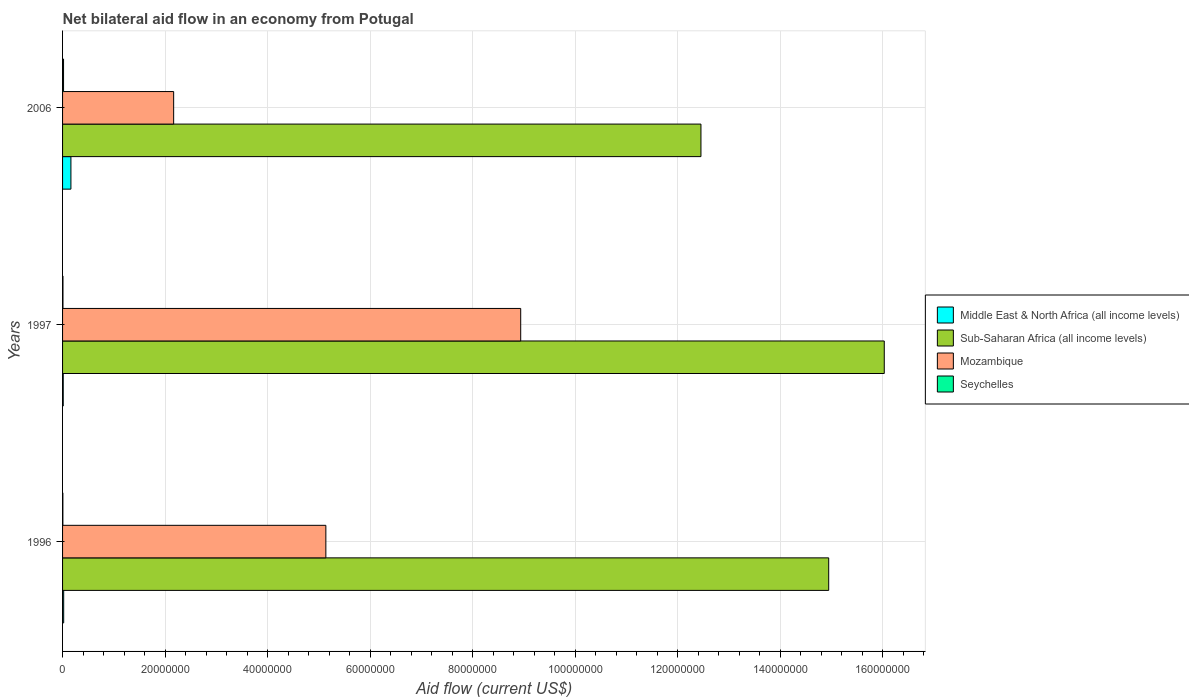How many different coloured bars are there?
Keep it short and to the point. 4. How many groups of bars are there?
Offer a very short reply. 3. Are the number of bars on each tick of the Y-axis equal?
Offer a very short reply. Yes. How many bars are there on the 2nd tick from the top?
Offer a terse response. 4. In how many cases, is the number of bars for a given year not equal to the number of legend labels?
Make the answer very short. 0. What is the net bilateral aid flow in Middle East & North Africa (all income levels) in 1997?
Make the answer very short. 1.30e+05. Across all years, what is the maximum net bilateral aid flow in Seychelles?
Offer a very short reply. 1.90e+05. Across all years, what is the minimum net bilateral aid flow in Sub-Saharan Africa (all income levels)?
Keep it short and to the point. 1.25e+08. In which year was the net bilateral aid flow in Mozambique minimum?
Offer a very short reply. 2006. What is the total net bilateral aid flow in Mozambique in the graph?
Offer a very short reply. 1.62e+08. What is the difference between the net bilateral aid flow in Sub-Saharan Africa (all income levels) in 1996 and that in 1997?
Offer a very short reply. -1.08e+07. What is the difference between the net bilateral aid flow in Middle East & North Africa (all income levels) in 2006 and the net bilateral aid flow in Sub-Saharan Africa (all income levels) in 1997?
Offer a very short reply. -1.59e+08. What is the average net bilateral aid flow in Middle East & North Africa (all income levels) per year?
Offer a terse response. 6.60e+05. In the year 1997, what is the difference between the net bilateral aid flow in Sub-Saharan Africa (all income levels) and net bilateral aid flow in Mozambique?
Give a very brief answer. 7.09e+07. What is the ratio of the net bilateral aid flow in Mozambique in 1996 to that in 2006?
Your answer should be compact. 2.37. What is the difference between the highest and the second highest net bilateral aid flow in Sub-Saharan Africa (all income levels)?
Make the answer very short. 1.08e+07. What is the difference between the highest and the lowest net bilateral aid flow in Mozambique?
Give a very brief answer. 6.77e+07. Is the sum of the net bilateral aid flow in Mozambique in 1996 and 1997 greater than the maximum net bilateral aid flow in Sub-Saharan Africa (all income levels) across all years?
Your answer should be compact. No. What does the 2nd bar from the top in 1996 represents?
Make the answer very short. Mozambique. What does the 1st bar from the bottom in 1997 represents?
Ensure brevity in your answer.  Middle East & North Africa (all income levels). How many bars are there?
Provide a succinct answer. 12. How many years are there in the graph?
Your answer should be very brief. 3. Does the graph contain any zero values?
Your response must be concise. No. How are the legend labels stacked?
Provide a succinct answer. Vertical. What is the title of the graph?
Your answer should be very brief. Net bilateral aid flow in an economy from Potugal. What is the Aid flow (current US$) of Middle East & North Africa (all income levels) in 1996?
Keep it short and to the point. 2.20e+05. What is the Aid flow (current US$) in Sub-Saharan Africa (all income levels) in 1996?
Ensure brevity in your answer.  1.49e+08. What is the Aid flow (current US$) in Mozambique in 1996?
Provide a short and direct response. 5.14e+07. What is the Aid flow (current US$) of Seychelles in 1996?
Make the answer very short. 6.00e+04. What is the Aid flow (current US$) in Sub-Saharan Africa (all income levels) in 1997?
Make the answer very short. 1.60e+08. What is the Aid flow (current US$) in Mozambique in 1997?
Offer a terse response. 8.94e+07. What is the Aid flow (current US$) of Middle East & North Africa (all income levels) in 2006?
Your answer should be compact. 1.63e+06. What is the Aid flow (current US$) of Sub-Saharan Africa (all income levels) in 2006?
Your response must be concise. 1.25e+08. What is the Aid flow (current US$) of Mozambique in 2006?
Ensure brevity in your answer.  2.17e+07. Across all years, what is the maximum Aid flow (current US$) of Middle East & North Africa (all income levels)?
Offer a very short reply. 1.63e+06. Across all years, what is the maximum Aid flow (current US$) in Sub-Saharan Africa (all income levels)?
Give a very brief answer. 1.60e+08. Across all years, what is the maximum Aid flow (current US$) in Mozambique?
Your response must be concise. 8.94e+07. Across all years, what is the maximum Aid flow (current US$) in Seychelles?
Ensure brevity in your answer.  1.90e+05. Across all years, what is the minimum Aid flow (current US$) of Sub-Saharan Africa (all income levels)?
Provide a short and direct response. 1.25e+08. Across all years, what is the minimum Aid flow (current US$) in Mozambique?
Ensure brevity in your answer.  2.17e+07. Across all years, what is the minimum Aid flow (current US$) in Seychelles?
Offer a very short reply. 6.00e+04. What is the total Aid flow (current US$) of Middle East & North Africa (all income levels) in the graph?
Make the answer very short. 1.98e+06. What is the total Aid flow (current US$) in Sub-Saharan Africa (all income levels) in the graph?
Offer a terse response. 4.34e+08. What is the total Aid flow (current US$) in Mozambique in the graph?
Provide a succinct answer. 1.62e+08. What is the difference between the Aid flow (current US$) of Middle East & North Africa (all income levels) in 1996 and that in 1997?
Give a very brief answer. 9.00e+04. What is the difference between the Aid flow (current US$) of Sub-Saharan Africa (all income levels) in 1996 and that in 1997?
Offer a very short reply. -1.08e+07. What is the difference between the Aid flow (current US$) in Mozambique in 1996 and that in 1997?
Your response must be concise. -3.80e+07. What is the difference between the Aid flow (current US$) in Middle East & North Africa (all income levels) in 1996 and that in 2006?
Provide a succinct answer. -1.41e+06. What is the difference between the Aid flow (current US$) of Sub-Saharan Africa (all income levels) in 1996 and that in 2006?
Your answer should be very brief. 2.49e+07. What is the difference between the Aid flow (current US$) in Mozambique in 1996 and that in 2006?
Your answer should be compact. 2.97e+07. What is the difference between the Aid flow (current US$) of Middle East & North Africa (all income levels) in 1997 and that in 2006?
Provide a short and direct response. -1.50e+06. What is the difference between the Aid flow (current US$) of Sub-Saharan Africa (all income levels) in 1997 and that in 2006?
Your answer should be compact. 3.58e+07. What is the difference between the Aid flow (current US$) in Mozambique in 1997 and that in 2006?
Provide a succinct answer. 6.77e+07. What is the difference between the Aid flow (current US$) of Middle East & North Africa (all income levels) in 1996 and the Aid flow (current US$) of Sub-Saharan Africa (all income levels) in 1997?
Your response must be concise. -1.60e+08. What is the difference between the Aid flow (current US$) in Middle East & North Africa (all income levels) in 1996 and the Aid flow (current US$) in Mozambique in 1997?
Your answer should be very brief. -8.92e+07. What is the difference between the Aid flow (current US$) of Middle East & North Africa (all income levels) in 1996 and the Aid flow (current US$) of Seychelles in 1997?
Your answer should be compact. 1.40e+05. What is the difference between the Aid flow (current US$) of Sub-Saharan Africa (all income levels) in 1996 and the Aid flow (current US$) of Mozambique in 1997?
Ensure brevity in your answer.  6.01e+07. What is the difference between the Aid flow (current US$) in Sub-Saharan Africa (all income levels) in 1996 and the Aid flow (current US$) in Seychelles in 1997?
Make the answer very short. 1.49e+08. What is the difference between the Aid flow (current US$) of Mozambique in 1996 and the Aid flow (current US$) of Seychelles in 1997?
Offer a terse response. 5.13e+07. What is the difference between the Aid flow (current US$) in Middle East & North Africa (all income levels) in 1996 and the Aid flow (current US$) in Sub-Saharan Africa (all income levels) in 2006?
Offer a terse response. -1.24e+08. What is the difference between the Aid flow (current US$) in Middle East & North Africa (all income levels) in 1996 and the Aid flow (current US$) in Mozambique in 2006?
Your response must be concise. -2.14e+07. What is the difference between the Aid flow (current US$) of Middle East & North Africa (all income levels) in 1996 and the Aid flow (current US$) of Seychelles in 2006?
Keep it short and to the point. 3.00e+04. What is the difference between the Aid flow (current US$) in Sub-Saharan Africa (all income levels) in 1996 and the Aid flow (current US$) in Mozambique in 2006?
Provide a succinct answer. 1.28e+08. What is the difference between the Aid flow (current US$) in Sub-Saharan Africa (all income levels) in 1996 and the Aid flow (current US$) in Seychelles in 2006?
Ensure brevity in your answer.  1.49e+08. What is the difference between the Aid flow (current US$) in Mozambique in 1996 and the Aid flow (current US$) in Seychelles in 2006?
Your answer should be compact. 5.12e+07. What is the difference between the Aid flow (current US$) of Middle East & North Africa (all income levels) in 1997 and the Aid flow (current US$) of Sub-Saharan Africa (all income levels) in 2006?
Offer a very short reply. -1.24e+08. What is the difference between the Aid flow (current US$) of Middle East & North Africa (all income levels) in 1997 and the Aid flow (current US$) of Mozambique in 2006?
Your response must be concise. -2.15e+07. What is the difference between the Aid flow (current US$) of Sub-Saharan Africa (all income levels) in 1997 and the Aid flow (current US$) of Mozambique in 2006?
Offer a terse response. 1.39e+08. What is the difference between the Aid flow (current US$) of Sub-Saharan Africa (all income levels) in 1997 and the Aid flow (current US$) of Seychelles in 2006?
Your answer should be very brief. 1.60e+08. What is the difference between the Aid flow (current US$) of Mozambique in 1997 and the Aid flow (current US$) of Seychelles in 2006?
Make the answer very short. 8.92e+07. What is the average Aid flow (current US$) in Middle East & North Africa (all income levels) per year?
Offer a very short reply. 6.60e+05. What is the average Aid flow (current US$) in Sub-Saharan Africa (all income levels) per year?
Provide a short and direct response. 1.45e+08. What is the average Aid flow (current US$) in Mozambique per year?
Give a very brief answer. 5.41e+07. In the year 1996, what is the difference between the Aid flow (current US$) of Middle East & North Africa (all income levels) and Aid flow (current US$) of Sub-Saharan Africa (all income levels)?
Your answer should be very brief. -1.49e+08. In the year 1996, what is the difference between the Aid flow (current US$) of Middle East & North Africa (all income levels) and Aid flow (current US$) of Mozambique?
Your response must be concise. -5.11e+07. In the year 1996, what is the difference between the Aid flow (current US$) of Sub-Saharan Africa (all income levels) and Aid flow (current US$) of Mozambique?
Give a very brief answer. 9.81e+07. In the year 1996, what is the difference between the Aid flow (current US$) of Sub-Saharan Africa (all income levels) and Aid flow (current US$) of Seychelles?
Your answer should be very brief. 1.49e+08. In the year 1996, what is the difference between the Aid flow (current US$) of Mozambique and Aid flow (current US$) of Seychelles?
Provide a succinct answer. 5.13e+07. In the year 1997, what is the difference between the Aid flow (current US$) in Middle East & North Africa (all income levels) and Aid flow (current US$) in Sub-Saharan Africa (all income levels)?
Your response must be concise. -1.60e+08. In the year 1997, what is the difference between the Aid flow (current US$) in Middle East & North Africa (all income levels) and Aid flow (current US$) in Mozambique?
Offer a terse response. -8.92e+07. In the year 1997, what is the difference between the Aid flow (current US$) of Sub-Saharan Africa (all income levels) and Aid flow (current US$) of Mozambique?
Your answer should be compact. 7.09e+07. In the year 1997, what is the difference between the Aid flow (current US$) in Sub-Saharan Africa (all income levels) and Aid flow (current US$) in Seychelles?
Provide a short and direct response. 1.60e+08. In the year 1997, what is the difference between the Aid flow (current US$) of Mozambique and Aid flow (current US$) of Seychelles?
Your response must be concise. 8.93e+07. In the year 2006, what is the difference between the Aid flow (current US$) of Middle East & North Africa (all income levels) and Aid flow (current US$) of Sub-Saharan Africa (all income levels)?
Your answer should be very brief. -1.23e+08. In the year 2006, what is the difference between the Aid flow (current US$) of Middle East & North Africa (all income levels) and Aid flow (current US$) of Mozambique?
Ensure brevity in your answer.  -2.00e+07. In the year 2006, what is the difference between the Aid flow (current US$) of Middle East & North Africa (all income levels) and Aid flow (current US$) of Seychelles?
Keep it short and to the point. 1.44e+06. In the year 2006, what is the difference between the Aid flow (current US$) of Sub-Saharan Africa (all income levels) and Aid flow (current US$) of Mozambique?
Keep it short and to the point. 1.03e+08. In the year 2006, what is the difference between the Aid flow (current US$) in Sub-Saharan Africa (all income levels) and Aid flow (current US$) in Seychelles?
Your answer should be very brief. 1.24e+08. In the year 2006, what is the difference between the Aid flow (current US$) of Mozambique and Aid flow (current US$) of Seychelles?
Provide a short and direct response. 2.15e+07. What is the ratio of the Aid flow (current US$) in Middle East & North Africa (all income levels) in 1996 to that in 1997?
Your response must be concise. 1.69. What is the ratio of the Aid flow (current US$) of Sub-Saharan Africa (all income levels) in 1996 to that in 1997?
Offer a very short reply. 0.93. What is the ratio of the Aid flow (current US$) in Mozambique in 1996 to that in 1997?
Your answer should be compact. 0.57. What is the ratio of the Aid flow (current US$) of Middle East & North Africa (all income levels) in 1996 to that in 2006?
Offer a very short reply. 0.14. What is the ratio of the Aid flow (current US$) in Sub-Saharan Africa (all income levels) in 1996 to that in 2006?
Offer a terse response. 1.2. What is the ratio of the Aid flow (current US$) of Mozambique in 1996 to that in 2006?
Ensure brevity in your answer.  2.37. What is the ratio of the Aid flow (current US$) of Seychelles in 1996 to that in 2006?
Offer a terse response. 0.32. What is the ratio of the Aid flow (current US$) of Middle East & North Africa (all income levels) in 1997 to that in 2006?
Keep it short and to the point. 0.08. What is the ratio of the Aid flow (current US$) of Sub-Saharan Africa (all income levels) in 1997 to that in 2006?
Your answer should be compact. 1.29. What is the ratio of the Aid flow (current US$) of Mozambique in 1997 to that in 2006?
Offer a very short reply. 4.12. What is the ratio of the Aid flow (current US$) of Seychelles in 1997 to that in 2006?
Ensure brevity in your answer.  0.42. What is the difference between the highest and the second highest Aid flow (current US$) of Middle East & North Africa (all income levels)?
Your response must be concise. 1.41e+06. What is the difference between the highest and the second highest Aid flow (current US$) in Sub-Saharan Africa (all income levels)?
Your response must be concise. 1.08e+07. What is the difference between the highest and the second highest Aid flow (current US$) of Mozambique?
Ensure brevity in your answer.  3.80e+07. What is the difference between the highest and the lowest Aid flow (current US$) in Middle East & North Africa (all income levels)?
Provide a succinct answer. 1.50e+06. What is the difference between the highest and the lowest Aid flow (current US$) in Sub-Saharan Africa (all income levels)?
Offer a very short reply. 3.58e+07. What is the difference between the highest and the lowest Aid flow (current US$) in Mozambique?
Provide a succinct answer. 6.77e+07. 